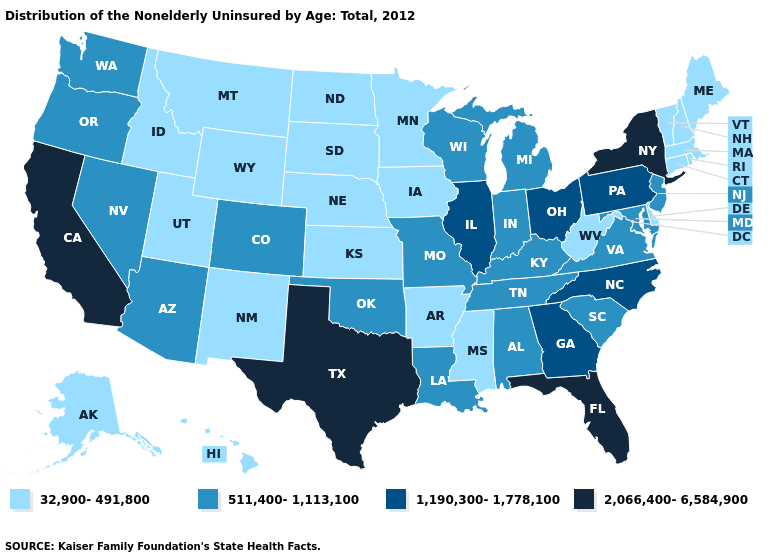Among the states that border Michigan , which have the lowest value?
Quick response, please. Indiana, Wisconsin. Does the first symbol in the legend represent the smallest category?
Quick response, please. Yes. Does New Hampshire have the lowest value in the USA?
Answer briefly. Yes. Among the states that border Iowa , which have the highest value?
Keep it brief. Illinois. Does Idaho have the lowest value in the USA?
Short answer required. Yes. Does Alabama have the highest value in the South?
Write a very short answer. No. Which states have the lowest value in the USA?
Quick response, please. Alaska, Arkansas, Connecticut, Delaware, Hawaii, Idaho, Iowa, Kansas, Maine, Massachusetts, Minnesota, Mississippi, Montana, Nebraska, New Hampshire, New Mexico, North Dakota, Rhode Island, South Dakota, Utah, Vermont, West Virginia, Wyoming. Name the states that have a value in the range 1,190,300-1,778,100?
Quick response, please. Georgia, Illinois, North Carolina, Ohio, Pennsylvania. What is the value of New Hampshire?
Answer briefly. 32,900-491,800. What is the lowest value in the USA?
Quick response, please. 32,900-491,800. Does the map have missing data?
Short answer required. No. What is the value of West Virginia?
Answer briefly. 32,900-491,800. Does the first symbol in the legend represent the smallest category?
Concise answer only. Yes. Name the states that have a value in the range 2,066,400-6,584,900?
Concise answer only. California, Florida, New York, Texas. 